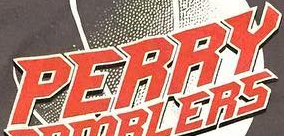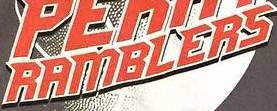What words can you see in these images in sequence, separated by a semicolon? PERRY; RAMBLERS 